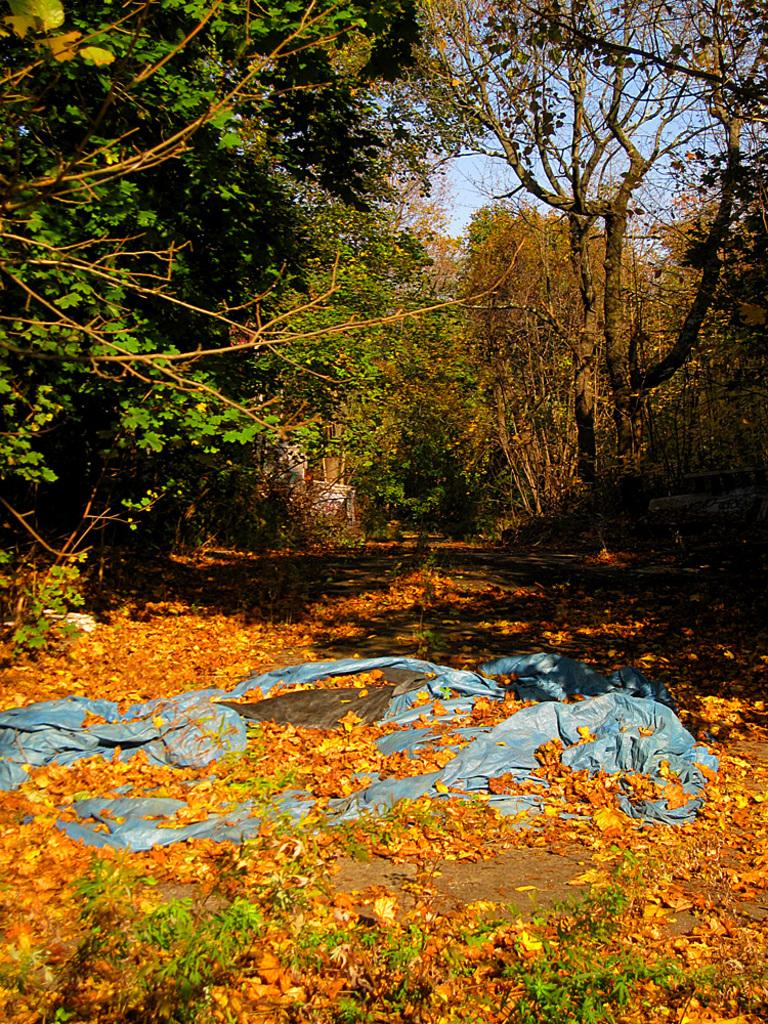What can be seen in the background of the image? There is a group of trees in the background of the image. What is present at the bottom of the image? There are dry leaves at the bottom of the image. How many rings are visible on the trees in the image? There are no rings visible on the trees in the image. What is the size of the dry leaves at the bottom of the image? The size of the dry leaves cannot be determined from the image alone, as it only provides a general view of the leaves. 